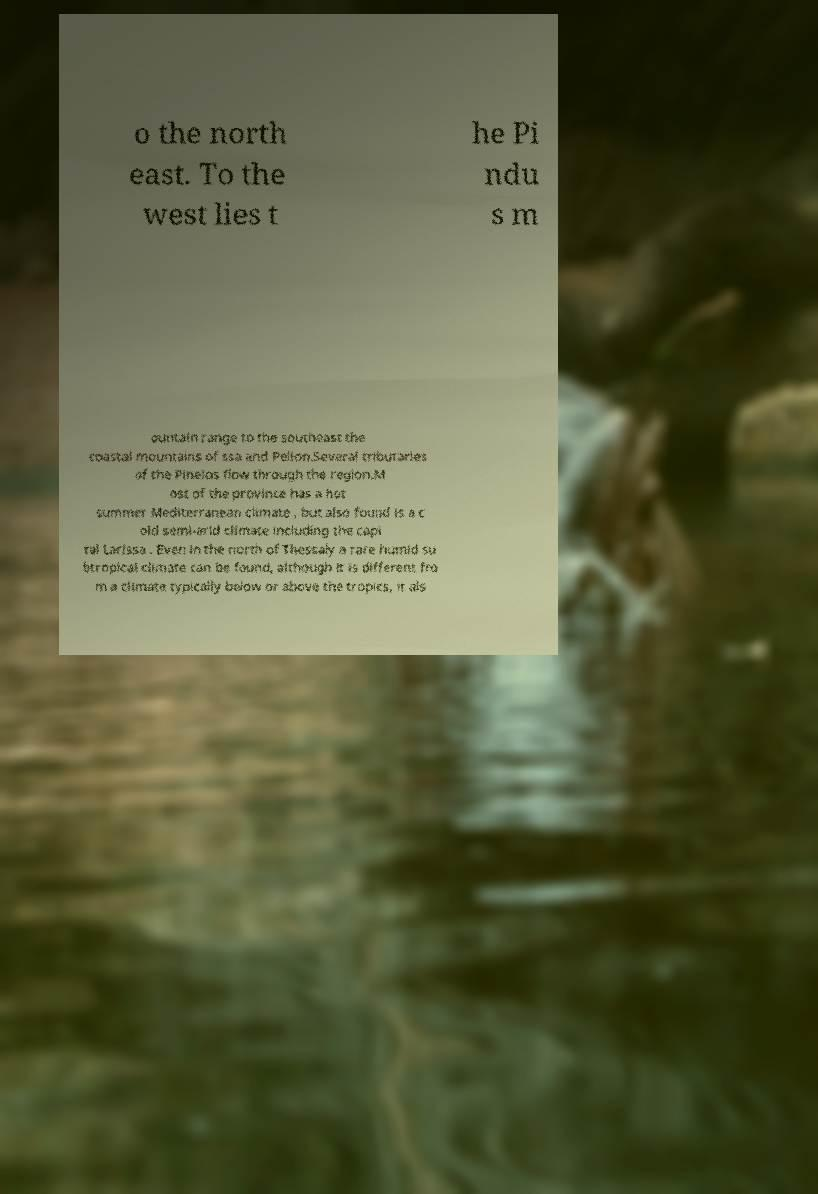For documentation purposes, I need the text within this image transcribed. Could you provide that? o the north east. To the west lies t he Pi ndu s m ountain range to the southeast the coastal mountains of ssa and Pelion.Several tributaries of the Pineios flow through the region.M ost of the province has a hot summer Mediterranean climate , but also found is a c old semi-arid climate including the capi tal Larissa . Even in the north of Thessaly a rare humid su btropical climate can be found, although it is different fro m a climate typically below or above the tropics, it als 